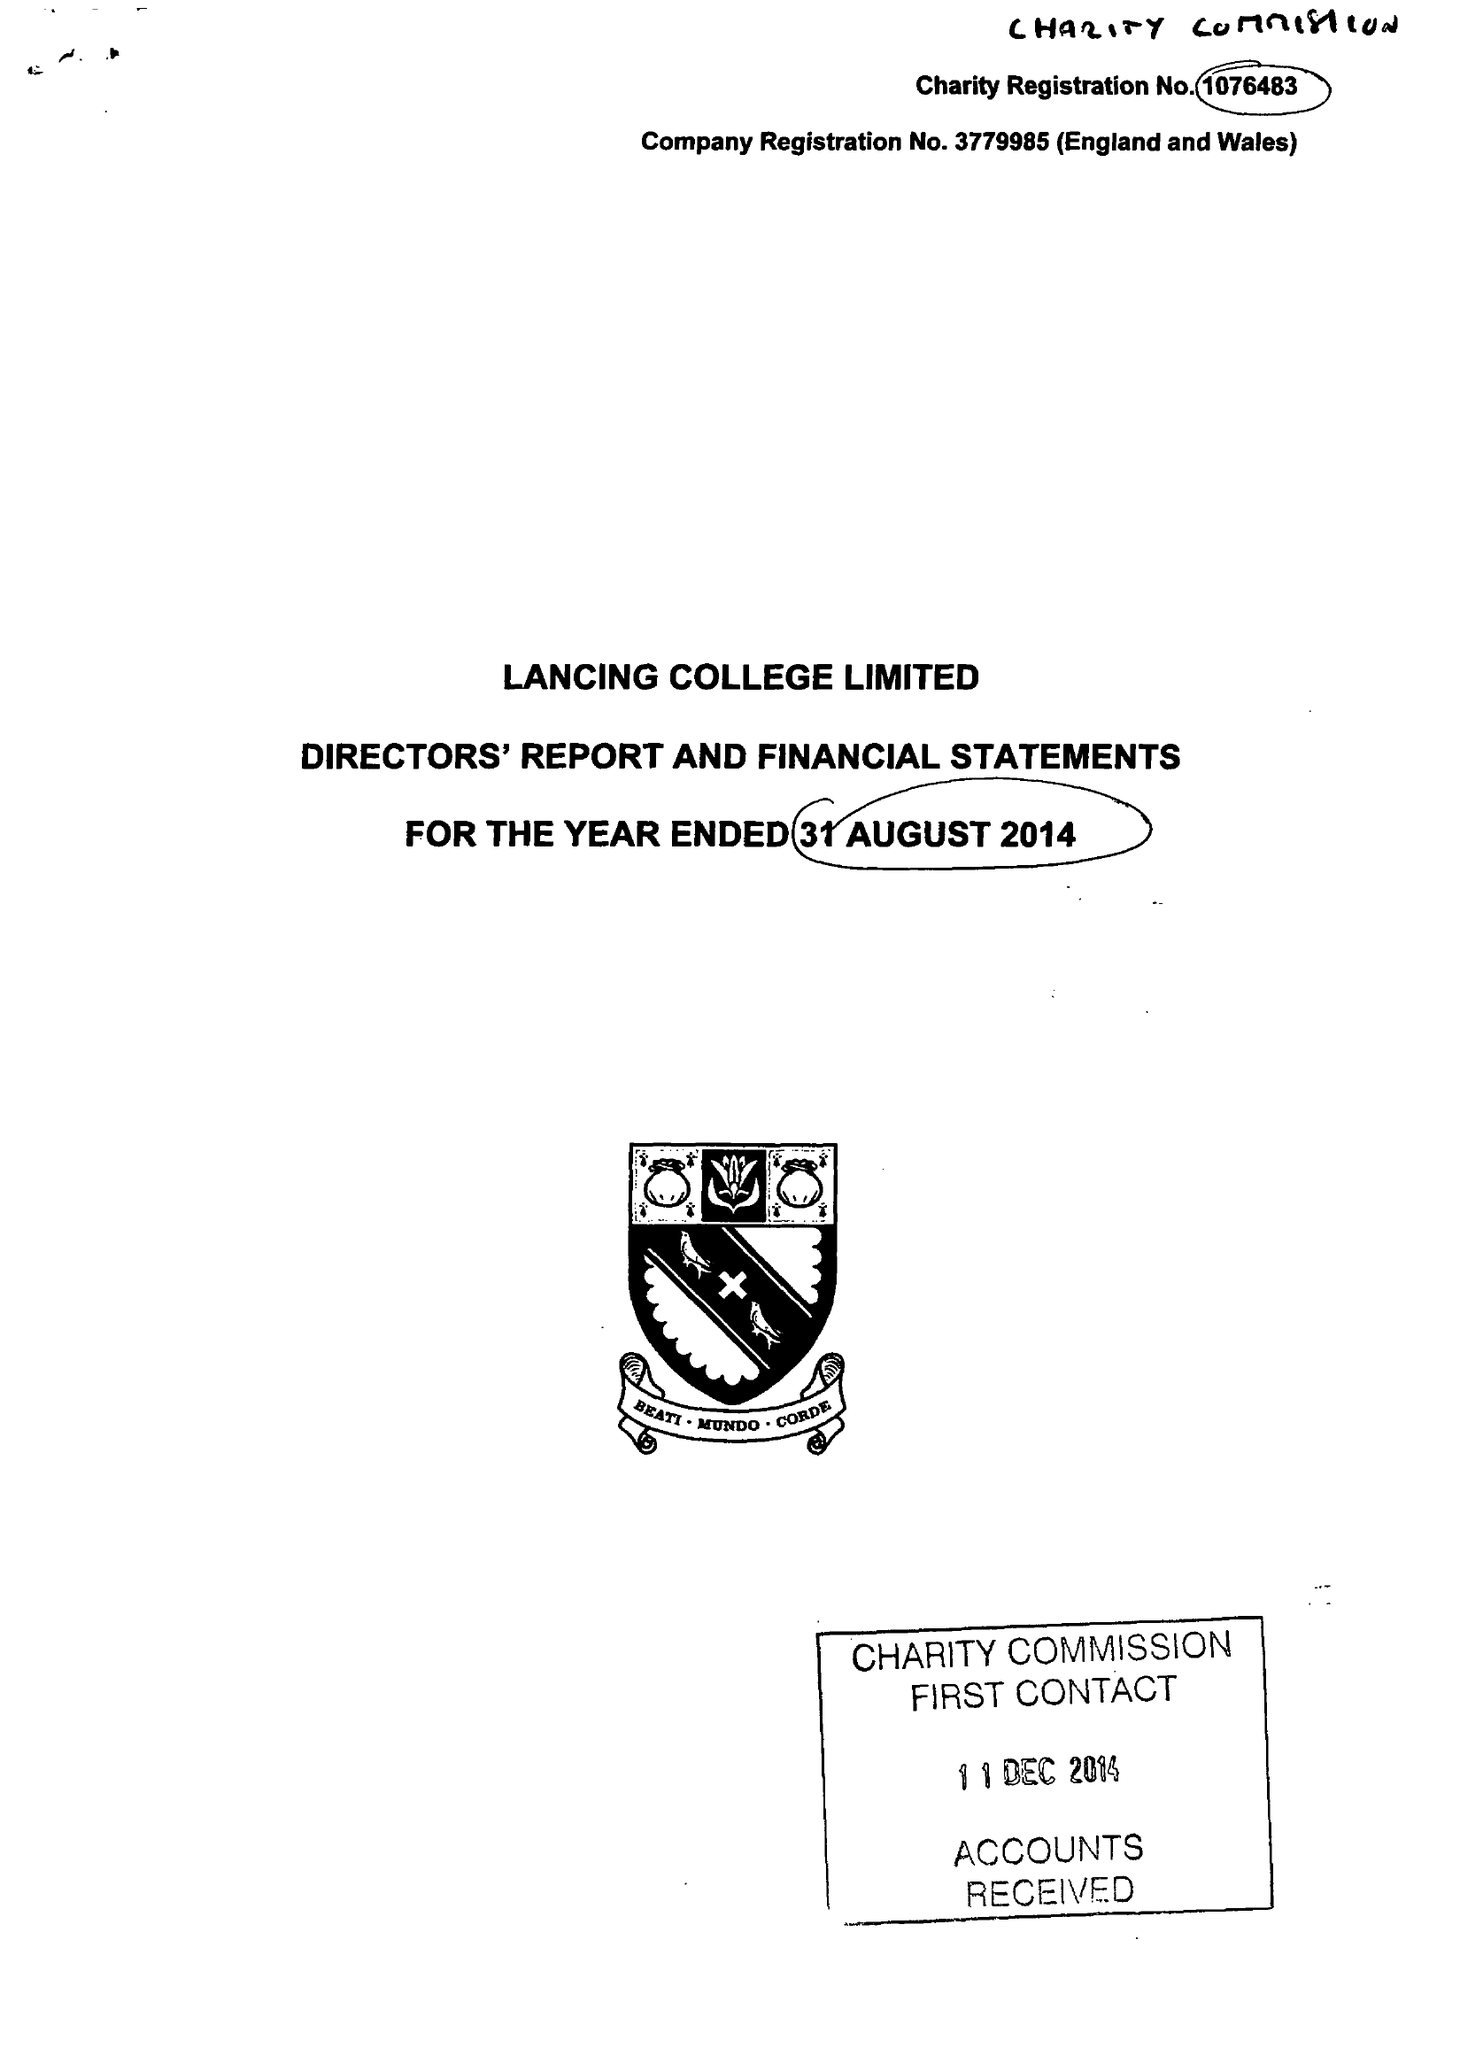What is the value for the report_date?
Answer the question using a single word or phrase. 2014-08-31 